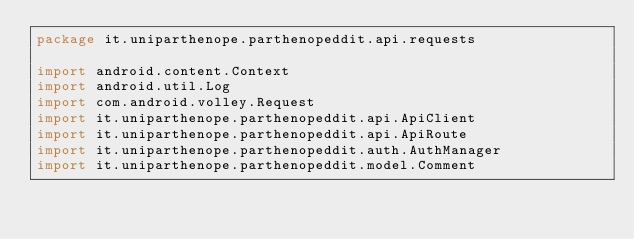<code> <loc_0><loc_0><loc_500><loc_500><_Kotlin_>package it.uniparthenope.parthenopeddit.api.requests

import android.content.Context
import android.util.Log
import com.android.volley.Request
import it.uniparthenope.parthenopeddit.api.ApiClient
import it.uniparthenope.parthenopeddit.api.ApiRoute
import it.uniparthenope.parthenopeddit.auth.AuthManager
import it.uniparthenope.parthenopeddit.model.Comment</code> 